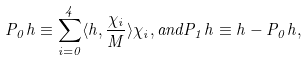<formula> <loc_0><loc_0><loc_500><loc_500>P _ { 0 } h \equiv \sum _ { i = 0 } ^ { 4 } \langle h , \frac { \chi _ { i } } { M } \rangle \chi _ { i } , a n d P _ { 1 } h \equiv h - P _ { 0 } h ,</formula> 